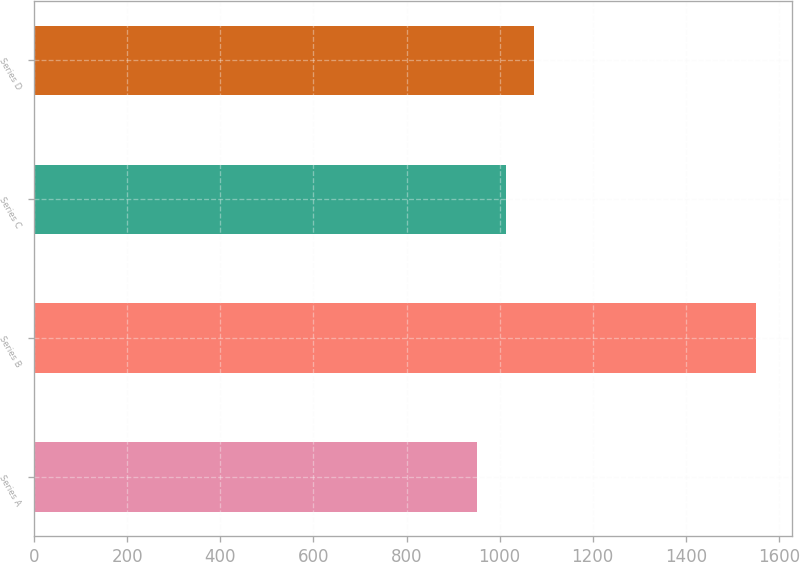Convert chart to OTSL. <chart><loc_0><loc_0><loc_500><loc_500><bar_chart><fcel>Series A<fcel>Series B<fcel>Series C<fcel>Series D<nl><fcel>950.51<fcel>1550<fcel>1013.9<fcel>1073.85<nl></chart> 